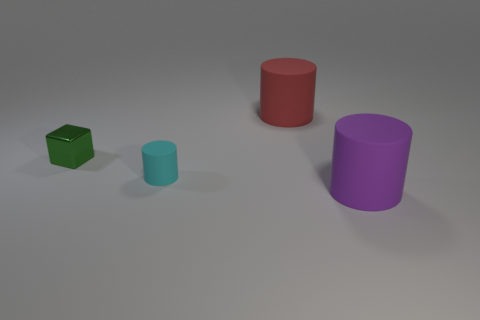Subtract all small cyan matte cylinders. How many cylinders are left? 2 Add 4 big gray rubber cylinders. How many objects exist? 8 Subtract all purple cylinders. How many cylinders are left? 2 Subtract all blocks. How many objects are left? 3 Subtract all purple cylinders. Subtract all cyan spheres. How many cylinders are left? 2 Subtract all purple cylinders. Subtract all large purple matte things. How many objects are left? 2 Add 2 large things. How many large things are left? 4 Add 2 rubber cylinders. How many rubber cylinders exist? 5 Subtract 0 blue spheres. How many objects are left? 4 Subtract 2 cylinders. How many cylinders are left? 1 